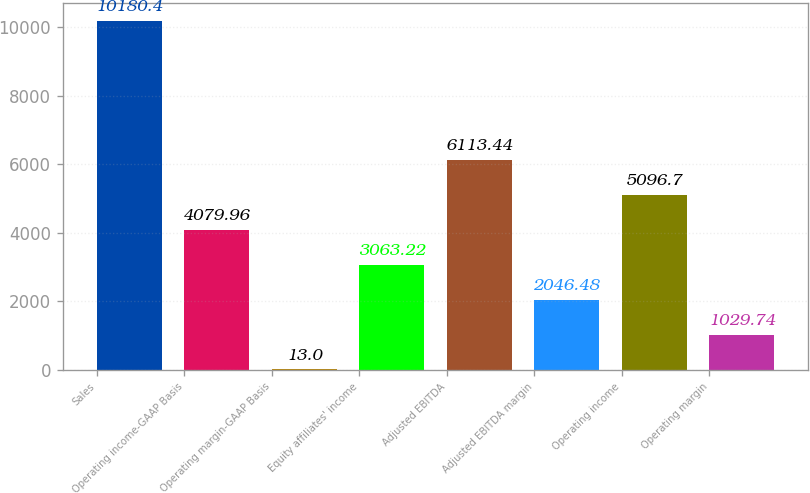<chart> <loc_0><loc_0><loc_500><loc_500><bar_chart><fcel>Sales<fcel>Operating income-GAAP Basis<fcel>Operating margin-GAAP Basis<fcel>Equity affiliates' income<fcel>Adjusted EBITDA<fcel>Adjusted EBITDA margin<fcel>Operating income<fcel>Operating margin<nl><fcel>10180.4<fcel>4079.96<fcel>13<fcel>3063.22<fcel>6113.44<fcel>2046.48<fcel>5096.7<fcel>1029.74<nl></chart> 